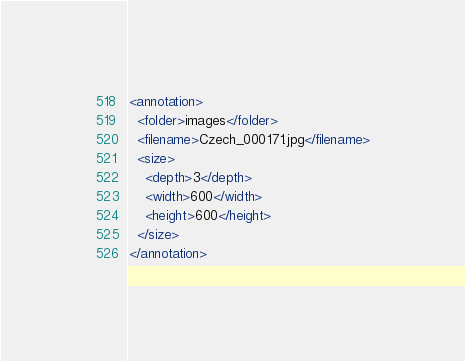<code> <loc_0><loc_0><loc_500><loc_500><_XML_><annotation>
  <folder>images</folder>
  <filename>Czech_000171.jpg</filename>
  <size>
    <depth>3</depth>
    <width>600</width>
    <height>600</height>
  </size>
</annotation></code> 